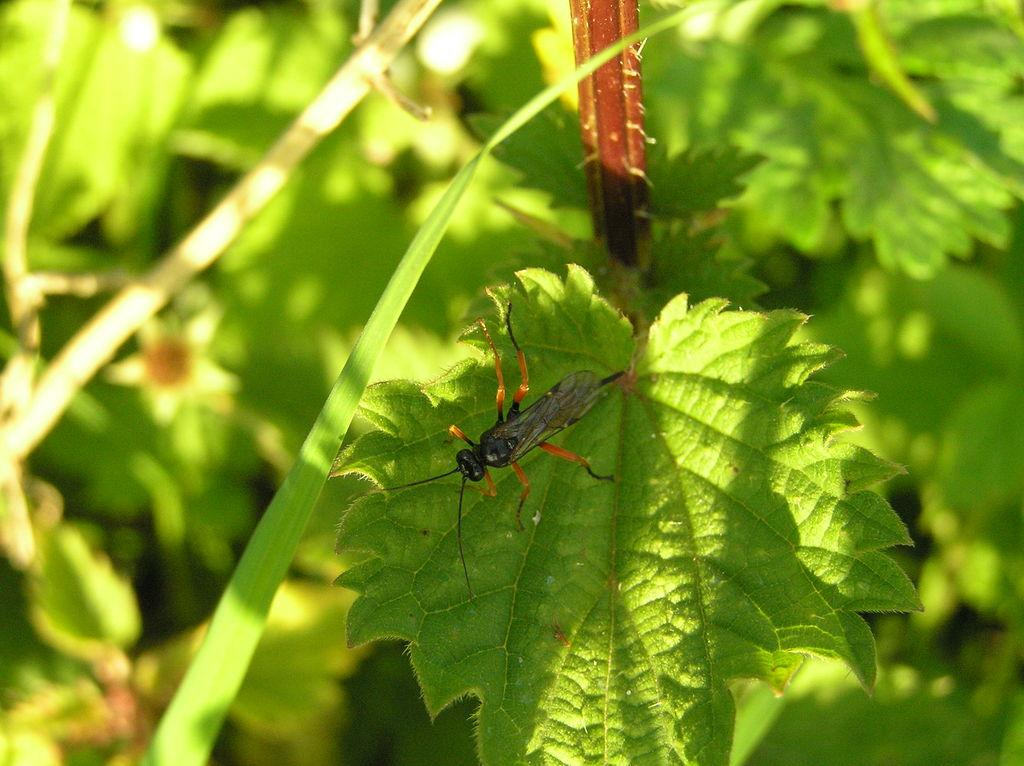What is on the leaf in the image? There is an insect on a leaf in the image. How is the leaf connected to the rest of the plant? The leaf appears to be attached to a stem. What can be seen in the background of the image? There are plants with green leaves in the background of the image. What type of business is being conducted in the image? There is no indication of any business activity in the image; it features an insect on a leaf and plants in the background. 